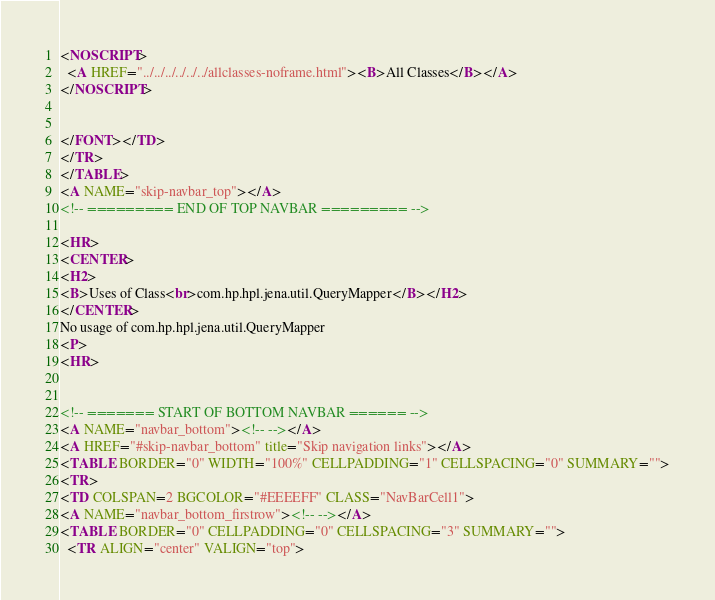Convert code to text. <code><loc_0><loc_0><loc_500><loc_500><_HTML_><NOSCRIPT>
  <A HREF="../../../../../../allclasses-noframe.html"><B>All Classes</B></A>
</NOSCRIPT>


</FONT></TD>
</TR>
</TABLE>
<A NAME="skip-navbar_top"></A>
<!-- ========= END OF TOP NAVBAR ========= -->

<HR>
<CENTER>
<H2>
<B>Uses of Class<br>com.hp.hpl.jena.util.QueryMapper</B></H2>
</CENTER>
No usage of com.hp.hpl.jena.util.QueryMapper
<P>
<HR>


<!-- ======= START OF BOTTOM NAVBAR ====== -->
<A NAME="navbar_bottom"><!-- --></A>
<A HREF="#skip-navbar_bottom" title="Skip navigation links"></A>
<TABLE BORDER="0" WIDTH="100%" CELLPADDING="1" CELLSPACING="0" SUMMARY="">
<TR>
<TD COLSPAN=2 BGCOLOR="#EEEEFF" CLASS="NavBarCell1">
<A NAME="navbar_bottom_firstrow"><!-- --></A>
<TABLE BORDER="0" CELLPADDING="0" CELLSPACING="3" SUMMARY="">
  <TR ALIGN="center" VALIGN="top"></code> 